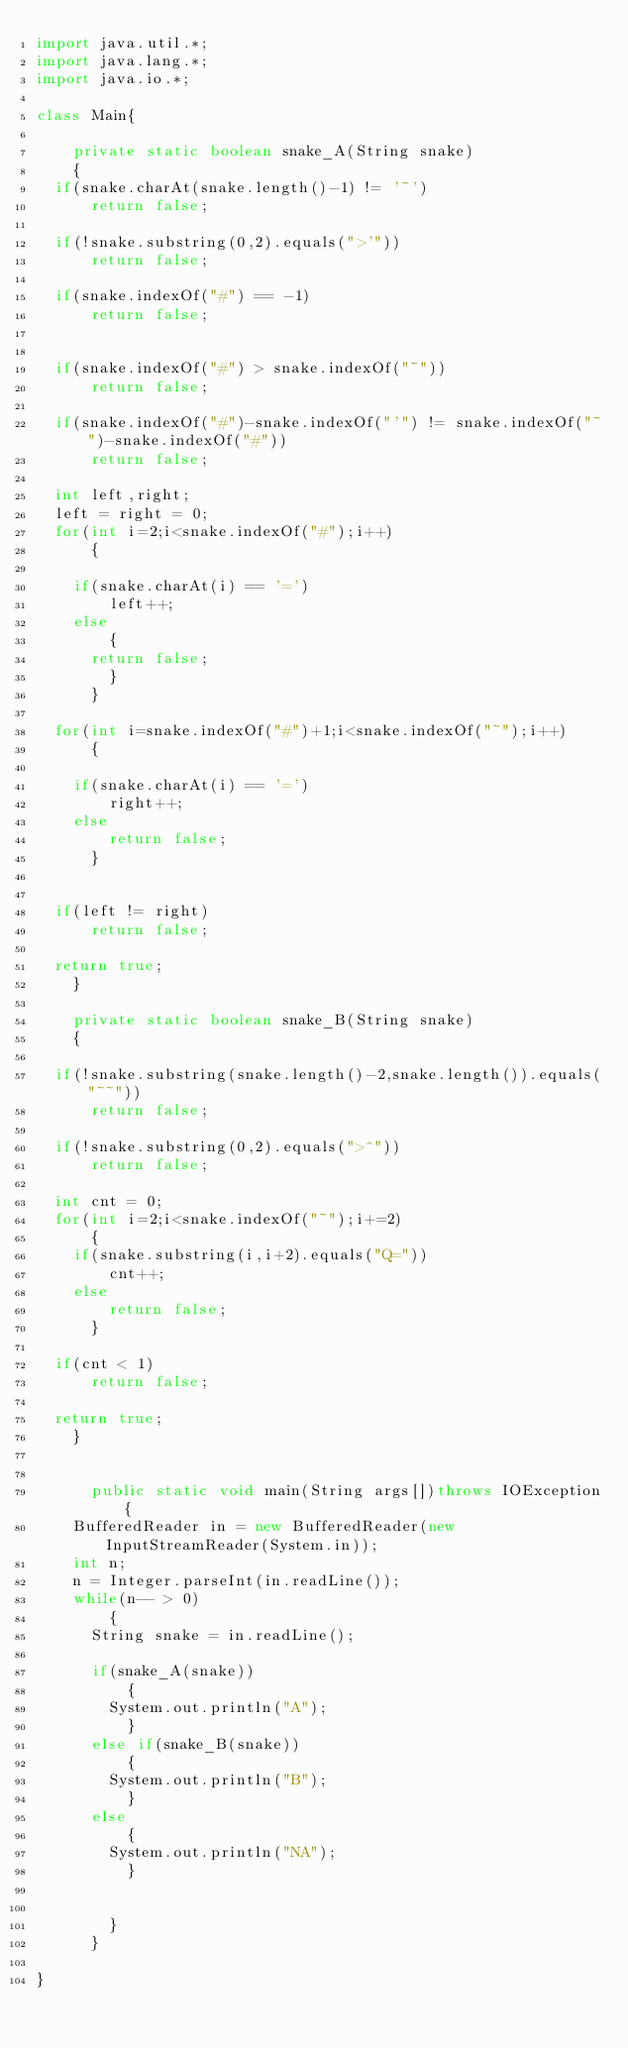<code> <loc_0><loc_0><loc_500><loc_500><_Java_>import java.util.*;
import java.lang.*;
import java.io.*;

class Main{

    private static boolean snake_A(String snake)
    {
	if(snake.charAt(snake.length()-1) != '~')
	    return false;

	if(!snake.substring(0,2).equals(">'"))		
	    return false;

	if(snake.indexOf("#") == -1)
	    return false;


	if(snake.indexOf("#") > snake.indexOf("~"))
	    return false;

	if(snake.indexOf("#")-snake.indexOf("'") != snake.indexOf("~")-snake.indexOf("#"))
	    return false;

	int left,right;
	left = right = 0;
	for(int i=2;i<snake.indexOf("#");i++)
	    {
	
		if(snake.charAt(i) == '=')
		    left++;
		else 
		    {
			return false;
		    }
	    }

	for(int i=snake.indexOf("#")+1;i<snake.indexOf("~");i++)
	    {
	
		if(snake.charAt(i) == '=')
		    right++;
		else 
		    return false;
	    }	

	
	if(left != right)
	    return false;

	return true;
    }

    private static boolean snake_B(String snake)
    {

	if(!snake.substring(snake.length()-2,snake.length()).equals("~~"))
	    return false;

	if(!snake.substring(0,2).equals(">^"))
	    return false;

	int cnt = 0;
	for(int i=2;i<snake.indexOf("~");i+=2)
	    {
		if(snake.substring(i,i+2).equals("Q="))
		    cnt++;
		else 
		    return false;
	    }

	if(cnt < 1)
	    return false;
	
	return true;
    }


      public static void main(String args[])throws IOException{
	  BufferedReader in = new BufferedReader(new InputStreamReader(System.in));
	  int n;
	  n = Integer.parseInt(in.readLine());
	  while(n-- > 0)
	      {
		  String snake = in.readLine();
		  
		  if(snake_A(snake))
		      {
			  System.out.println("A");
		      }
		  else if(snake_B(snake))
		      {
			  System.out.println("B");
		      }
		  else
		      {
			  System.out.println("NA");
		      }


	      }
      }

}</code> 